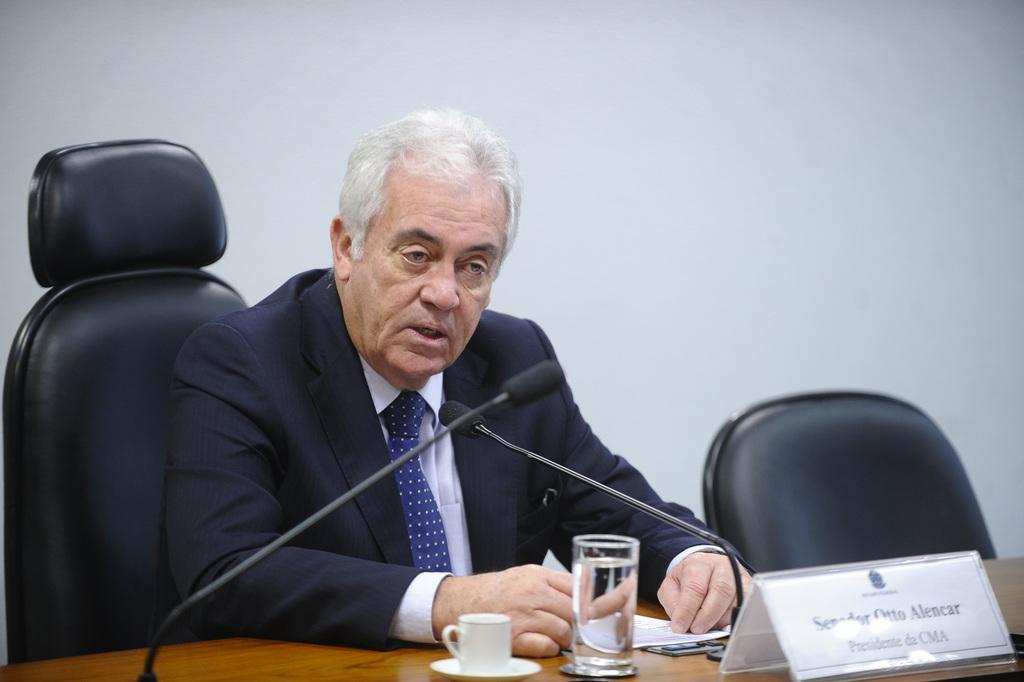Describe this image in one or two sentences. In this image a person is sitting on a chair. On the table there is a cup, glass of water, papers, name board, mics and objects. In the background of the image there is a wall.   